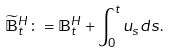<formula> <loc_0><loc_0><loc_500><loc_500>\widetilde { \mathbb { B } } _ { t } ^ { H } \colon = \mathbb { B } _ { t } ^ { H } + \int _ { 0 } ^ { t } u _ { s } d s .</formula> 